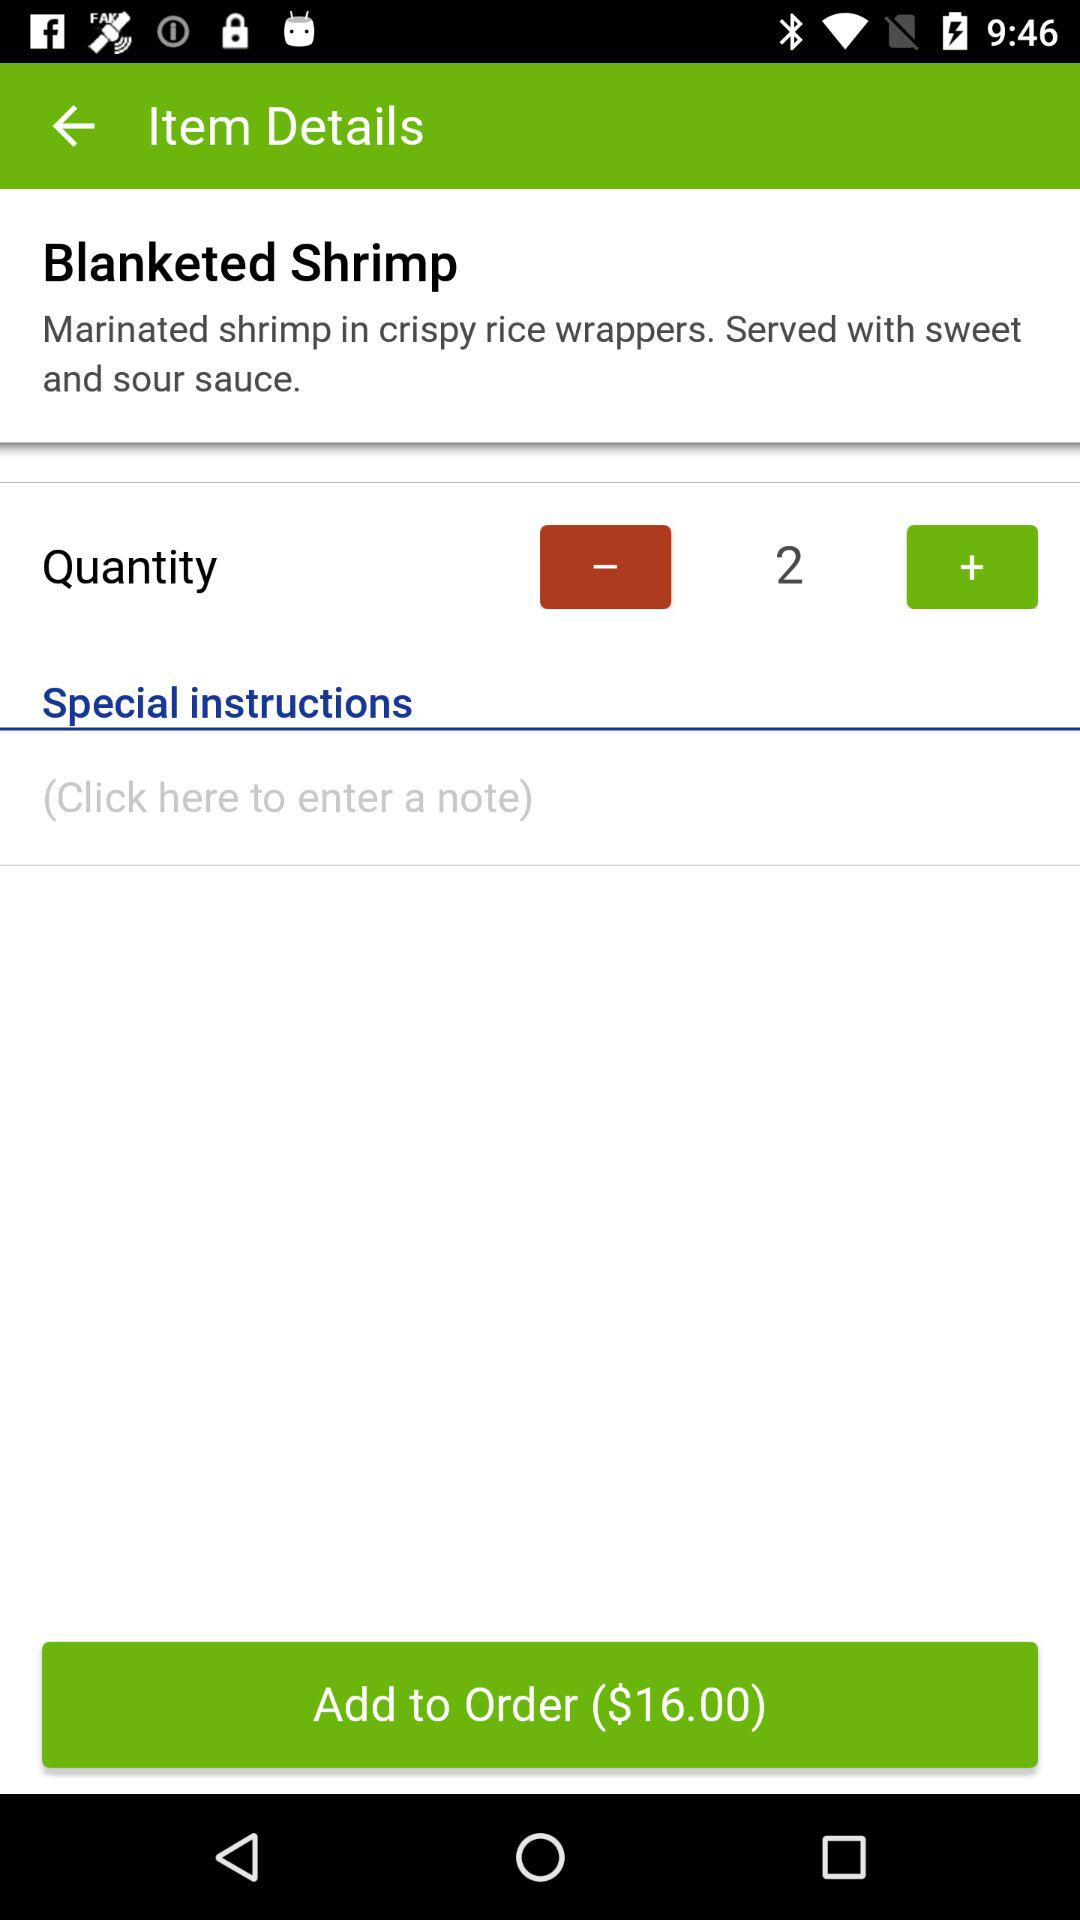What is the item name? The item is "Blanketed Shrimp". 